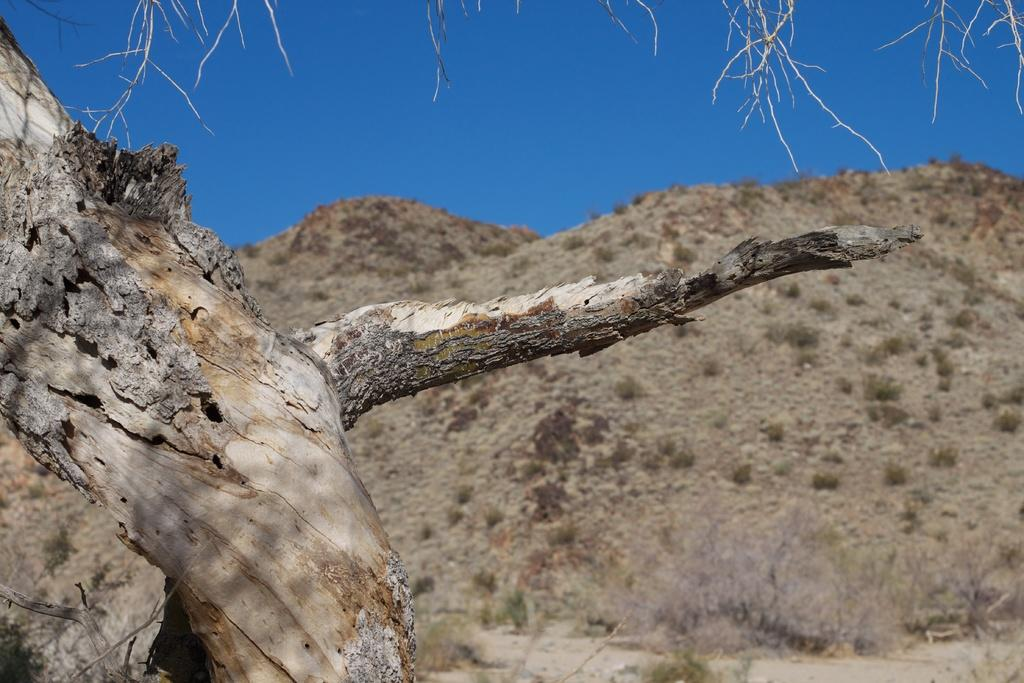What is the main geographical feature in the image? There is a mountain in the image. Are there any other objects or features near the mountain? Yes, there is a tree to the left of the mountain. What can be seen in the sky in the image? The sky is visible at the top of the image and is blue in color. What type of vase is on the mountain in the image? There is no vase present on the mountain in the image. Does the son need to climb the mountain in the image? There is no mention of a son or any person in the image, so it is impossible to determine if they need to climb the mountain. 